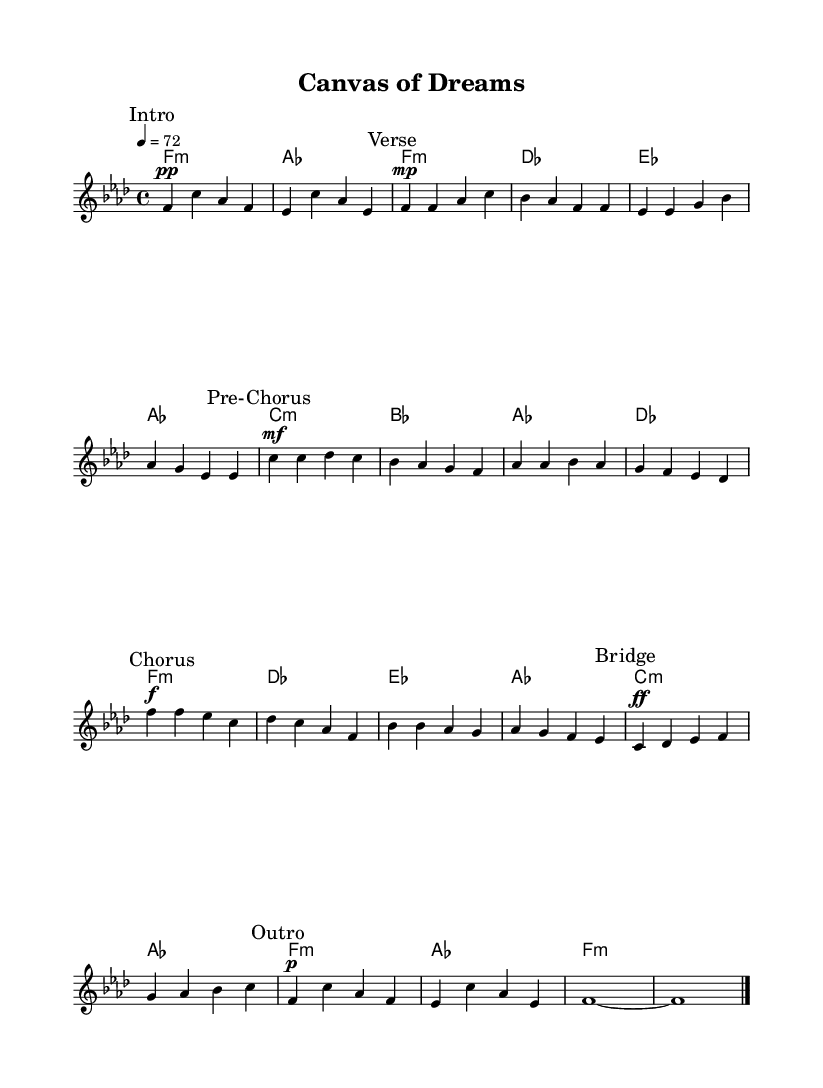What is the key signature of this music? The key signature is identified by the flattened notes in the music. In this case, there are four flats (B, E, A, and D), indicating that the key signature is F minor.
Answer: F minor What is the time signature of this music? The time signature indicates the rhythmic structure of the piece. Here, the time signature shown at the beginning is 4/4, meaning there are four beats in each measure.
Answer: 4/4 What is the tempo marking of this music? The tempo marking indicates the speed of the music. The marking given is "4 = 72", which specifies that the quarter note should be played at a speed of 72 beats per minute.
Answer: 72 Which section has the loudest dynamics? The dynamics in the music are represented by markings such as pp, mp, mf, and f. The section marked as "Chorus" is noted with an f (forte), indicating it is to be played loudly.
Answer: Chorus How many measures are in the "Bridge" section? The "Bridge" section starts with a specific marking and the measures following it can be counted. This section contains only two measures based on the notation seen in the sheet music.
Answer: 2 What is the first chord in the piece? The first chord is indicated in the harmonies section at the very beginning of the score, and it is written as f minor, which corresponds to the melody that follows.
Answer: f minor What style of music does this piece represent? This piece is created in the K-pop genre, which often includes introspective themes focusing on artistic struggles and the creative process, as indicated by the title "Canvas of Dreams".
Answer: K-pop 